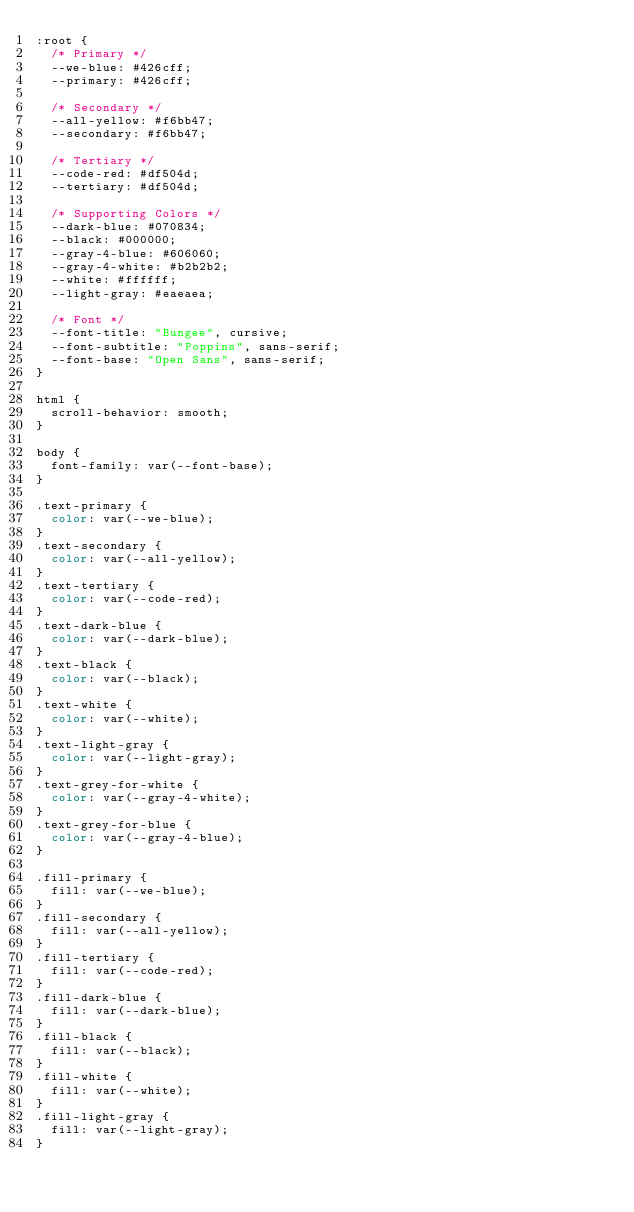<code> <loc_0><loc_0><loc_500><loc_500><_CSS_>:root {
  /* Primary */
  --we-blue: #426cff;
  --primary: #426cff;

  /* Secondary */
  --all-yellow: #f6bb47;
  --secondary: #f6bb47;

  /* Tertiary */
  --code-red: #df504d;
  --tertiary: #df504d;

  /* Supporting Colors */
  --dark-blue: #070834;
  --black: #000000;
  --gray-4-blue: #606060;
  --gray-4-white: #b2b2b2;
  --white: #ffffff;
  --light-gray: #eaeaea;

  /* Font */
  --font-title: "Bungee", cursive;
  --font-subtitle: "Poppins", sans-serif;
  --font-base: "Open Sans", sans-serif;
}

html {
  scroll-behavior: smooth;
}

body {
  font-family: var(--font-base);
}

.text-primary {
  color: var(--we-blue);
}
.text-secondary {
  color: var(--all-yellow);
}
.text-tertiary {
  color: var(--code-red);
}
.text-dark-blue {
  color: var(--dark-blue);
}
.text-black {
  color: var(--black);
}
.text-white {
  color: var(--white);
}
.text-light-gray {
  color: var(--light-gray);
}
.text-grey-for-white {
  color: var(--gray-4-white);
}
.text-grey-for-blue {
  color: var(--gray-4-blue);
}

.fill-primary {
  fill: var(--we-blue);
}
.fill-secondary {
  fill: var(--all-yellow);
}
.fill-tertiary {
  fill: var(--code-red);
}
.fill-dark-blue {
  fill: var(--dark-blue);
}
.fill-black {
  fill: var(--black);
}
.fill-white {
  fill: var(--white);
}
.fill-light-gray {
  fill: var(--light-gray);
}</code> 